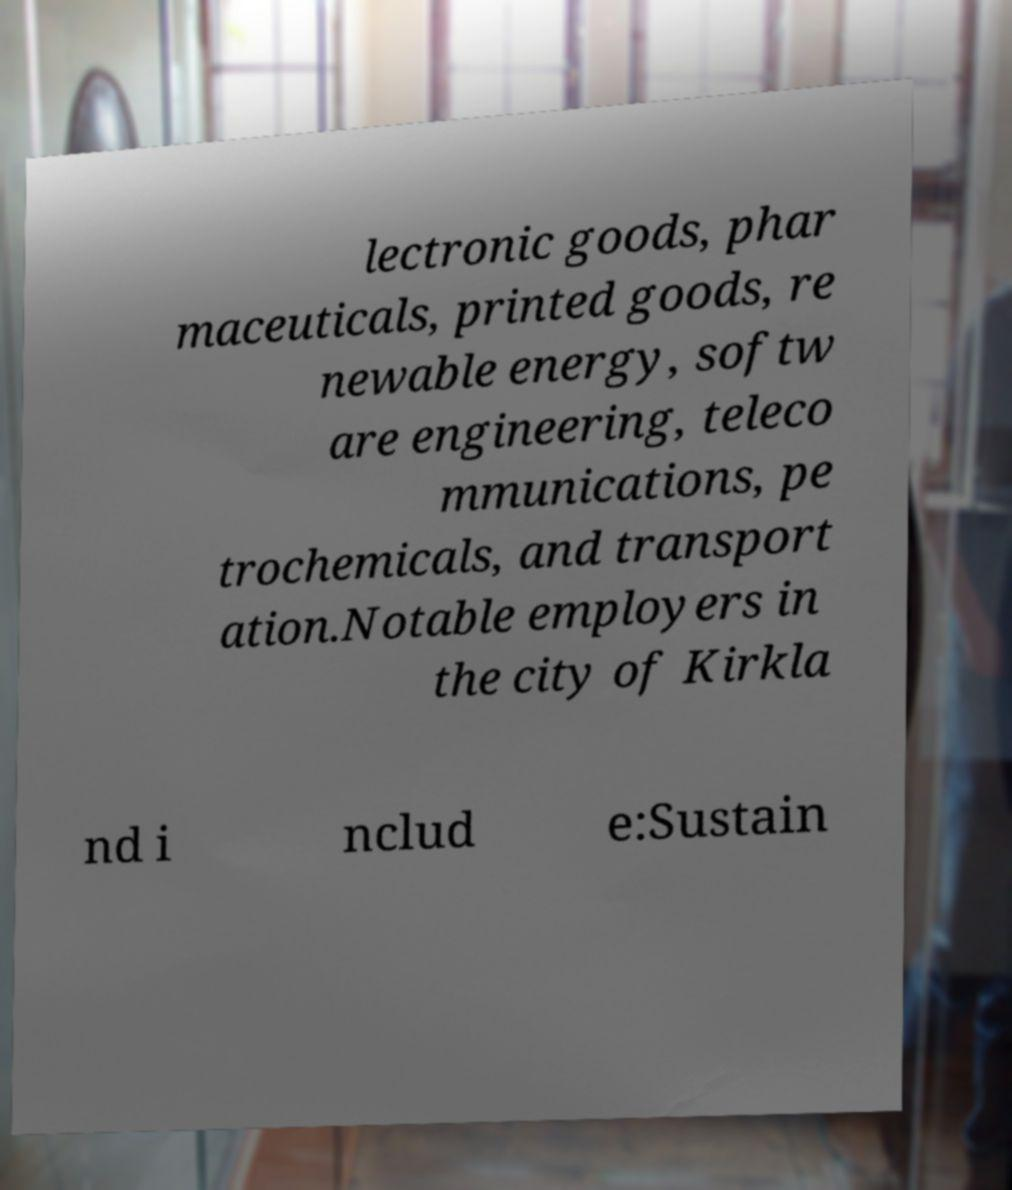I need the written content from this picture converted into text. Can you do that? lectronic goods, phar maceuticals, printed goods, re newable energy, softw are engineering, teleco mmunications, pe trochemicals, and transport ation.Notable employers in the city of Kirkla nd i nclud e:Sustain 